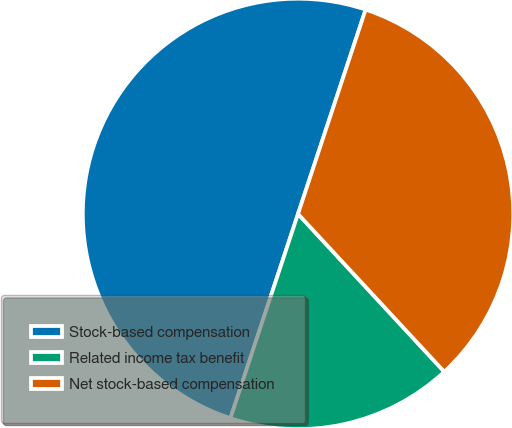Convert chart. <chart><loc_0><loc_0><loc_500><loc_500><pie_chart><fcel>Stock-based compensation<fcel>Related income tax benefit<fcel>Net stock-based compensation<nl><fcel>50.0%<fcel>16.98%<fcel>33.02%<nl></chart> 